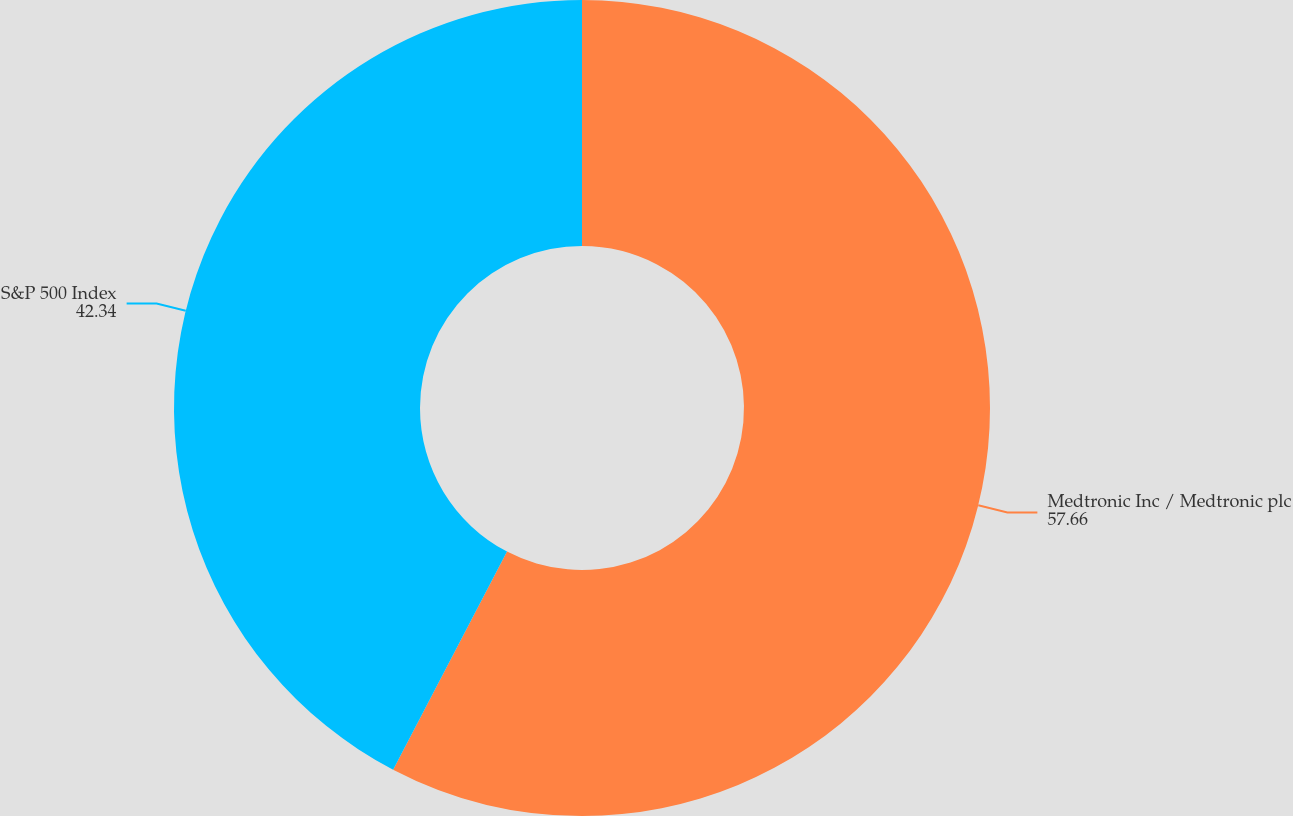Convert chart. <chart><loc_0><loc_0><loc_500><loc_500><pie_chart><fcel>Medtronic Inc / Medtronic plc<fcel>S&P 500 Index<nl><fcel>57.66%<fcel>42.34%<nl></chart> 